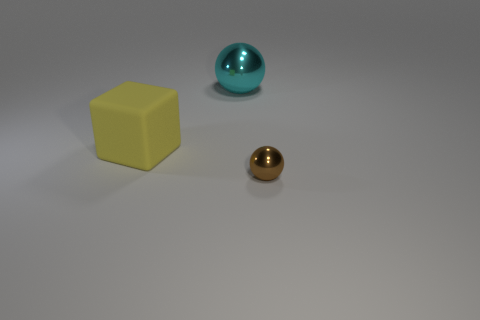Does the yellow matte object have the same shape as the big object behind the rubber thing? The yellow matte object is a cube, which has a distinctly different shape compared to the larger, spherical turquoise object behind the small, shiny, golden sphere. 